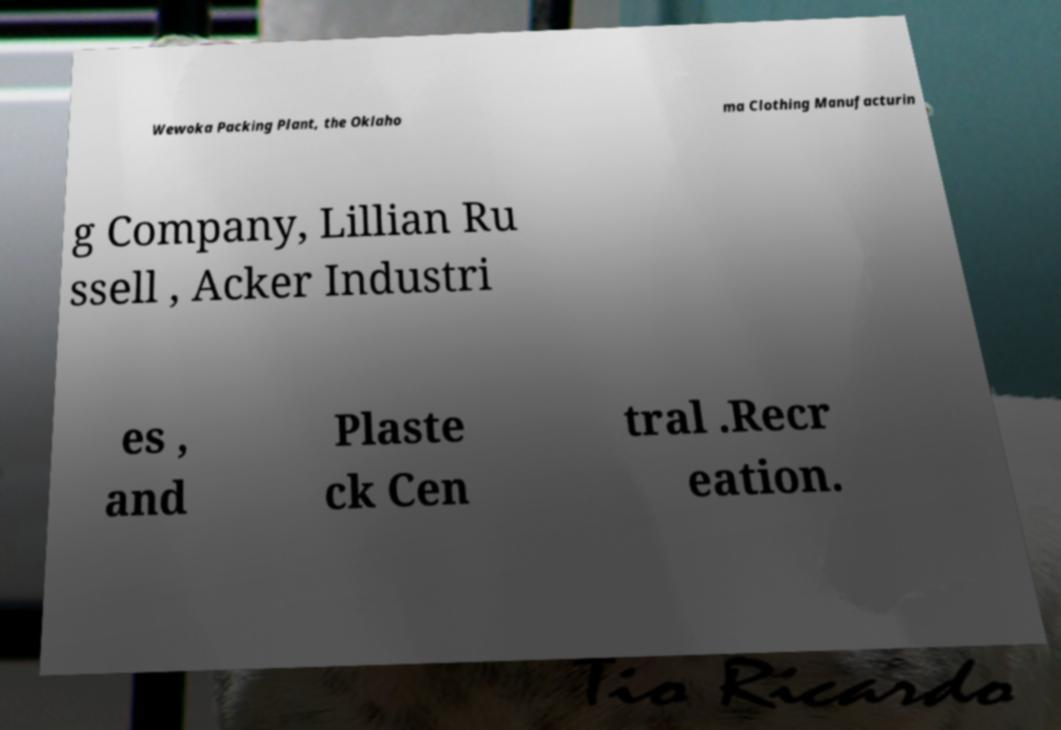I need the written content from this picture converted into text. Can you do that? Wewoka Packing Plant, the Oklaho ma Clothing Manufacturin g Company, Lillian Ru ssell , Acker Industri es , and Plaste ck Cen tral .Recr eation. 